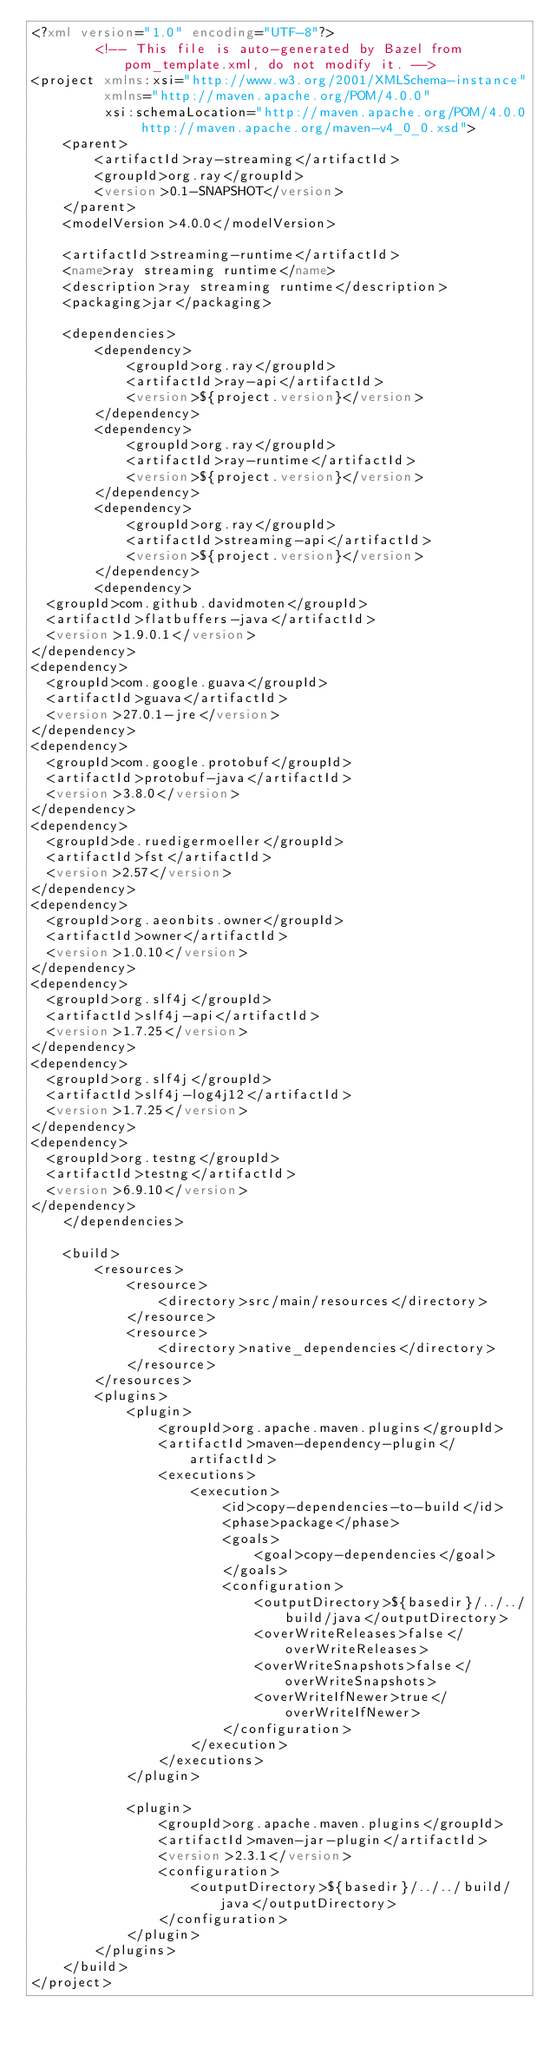<code> <loc_0><loc_0><loc_500><loc_500><_XML_><?xml version="1.0" encoding="UTF-8"?>
        <!-- This file is auto-generated by Bazel from pom_template.xml, do not modify it. -->
<project xmlns:xsi="http://www.w3.org/2001/XMLSchema-instance"
         xmlns="http://maven.apache.org/POM/4.0.0"
         xsi:schemaLocation="http://maven.apache.org/POM/4.0.0 http://maven.apache.org/maven-v4_0_0.xsd">
    <parent>
        <artifactId>ray-streaming</artifactId>
        <groupId>org.ray</groupId>
        <version>0.1-SNAPSHOT</version>
    </parent>
    <modelVersion>4.0.0</modelVersion>

    <artifactId>streaming-runtime</artifactId>
    <name>ray streaming runtime</name>
    <description>ray streaming runtime</description>
    <packaging>jar</packaging>

    <dependencies>
        <dependency>
            <groupId>org.ray</groupId>
            <artifactId>ray-api</artifactId>
            <version>${project.version}</version>
        </dependency>
        <dependency>
            <groupId>org.ray</groupId>
            <artifactId>ray-runtime</artifactId>
            <version>${project.version}</version>
        </dependency>
        <dependency>
            <groupId>org.ray</groupId>
            <artifactId>streaming-api</artifactId>
            <version>${project.version}</version>
        </dependency>
        <dependency>
  <groupId>com.github.davidmoten</groupId>
  <artifactId>flatbuffers-java</artifactId>
  <version>1.9.0.1</version>
</dependency>
<dependency>
  <groupId>com.google.guava</groupId>
  <artifactId>guava</artifactId>
  <version>27.0.1-jre</version>
</dependency>
<dependency>
  <groupId>com.google.protobuf</groupId>
  <artifactId>protobuf-java</artifactId>
  <version>3.8.0</version>
</dependency>
<dependency>
  <groupId>de.ruedigermoeller</groupId>
  <artifactId>fst</artifactId>
  <version>2.57</version>
</dependency>
<dependency>
  <groupId>org.aeonbits.owner</groupId>
  <artifactId>owner</artifactId>
  <version>1.0.10</version>
</dependency>
<dependency>
  <groupId>org.slf4j</groupId>
  <artifactId>slf4j-api</artifactId>
  <version>1.7.25</version>
</dependency>
<dependency>
  <groupId>org.slf4j</groupId>
  <artifactId>slf4j-log4j12</artifactId>
  <version>1.7.25</version>
</dependency>
<dependency>
  <groupId>org.testng</groupId>
  <artifactId>testng</artifactId>
  <version>6.9.10</version>
</dependency>
    </dependencies>

    <build>
        <resources>
            <resource>
                <directory>src/main/resources</directory>
            </resource>
            <resource>
                <directory>native_dependencies</directory>
            </resource>
        </resources>
        <plugins>
            <plugin>
                <groupId>org.apache.maven.plugins</groupId>
                <artifactId>maven-dependency-plugin</artifactId>
                <executions>
                    <execution>
                        <id>copy-dependencies-to-build</id>
                        <phase>package</phase>
                        <goals>
                            <goal>copy-dependencies</goal>
                        </goals>
                        <configuration>
                            <outputDirectory>${basedir}/../../build/java</outputDirectory>
                            <overWriteReleases>false</overWriteReleases>
                            <overWriteSnapshots>false</overWriteSnapshots>
                            <overWriteIfNewer>true</overWriteIfNewer>
                        </configuration>
                    </execution>
                </executions>
            </plugin>

            <plugin>
                <groupId>org.apache.maven.plugins</groupId>
                <artifactId>maven-jar-plugin</artifactId>
                <version>2.3.1</version>
                <configuration>
                    <outputDirectory>${basedir}/../../build/java</outputDirectory>
                </configuration>
            </plugin>
        </plugins>
    </build>
</project>
</code> 